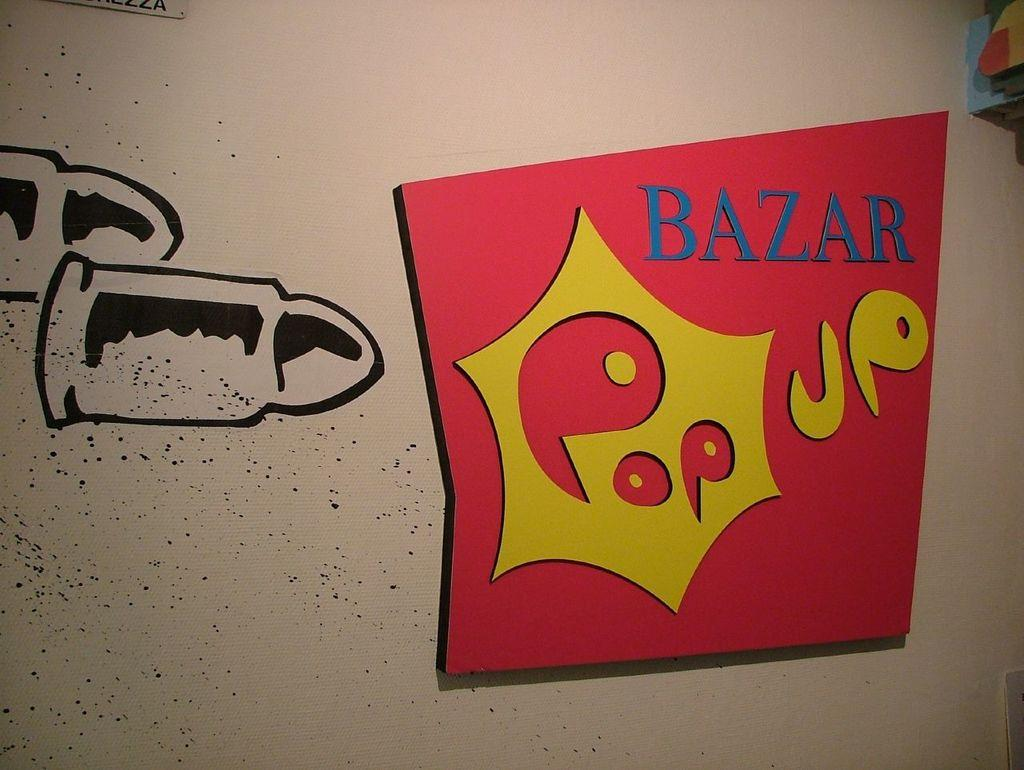<image>
Offer a succinct explanation of the picture presented. Words that say Bazar Pop up on a wall next to a drawing of a bullet. 